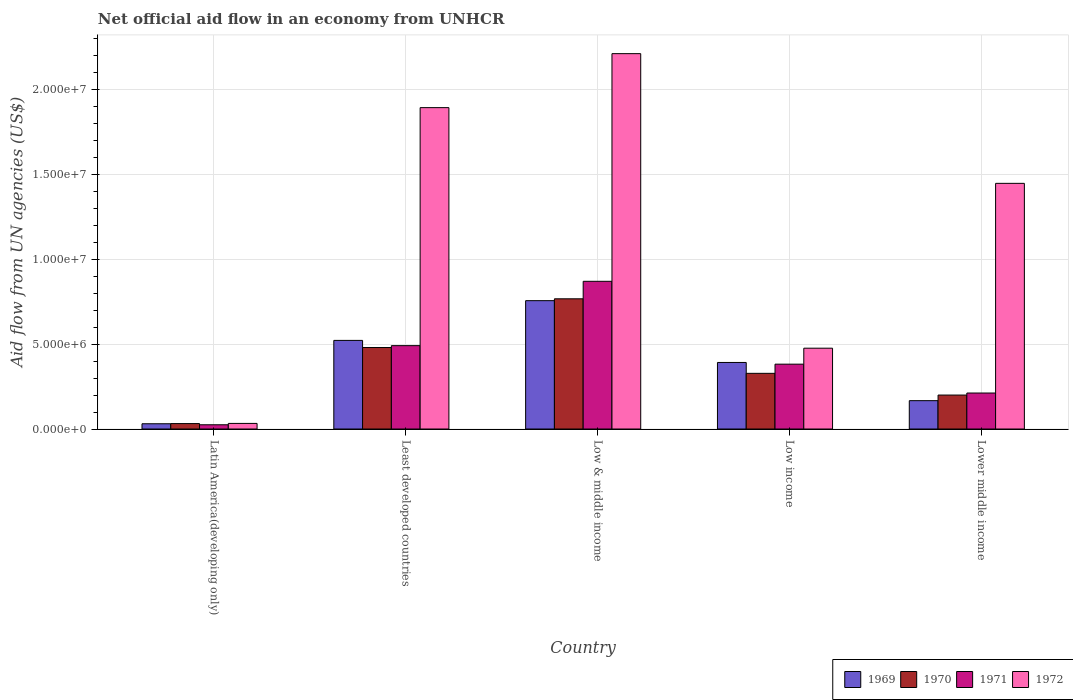How many different coloured bars are there?
Offer a terse response. 4. Are the number of bars on each tick of the X-axis equal?
Your response must be concise. Yes. How many bars are there on the 3rd tick from the left?
Keep it short and to the point. 4. How many bars are there on the 1st tick from the right?
Your answer should be compact. 4. What is the label of the 5th group of bars from the left?
Offer a terse response. Lower middle income. In how many cases, is the number of bars for a given country not equal to the number of legend labels?
Your answer should be very brief. 0. What is the net official aid flow in 1972 in Low & middle income?
Make the answer very short. 2.21e+07. Across all countries, what is the maximum net official aid flow in 1972?
Your answer should be very brief. 2.21e+07. Across all countries, what is the minimum net official aid flow in 1971?
Your response must be concise. 2.50e+05. In which country was the net official aid flow in 1971 maximum?
Provide a short and direct response. Low & middle income. In which country was the net official aid flow in 1971 minimum?
Your answer should be very brief. Latin America(developing only). What is the total net official aid flow in 1972 in the graph?
Keep it short and to the point. 6.06e+07. What is the difference between the net official aid flow in 1969 in Latin America(developing only) and that in Least developed countries?
Your answer should be compact. -4.91e+06. What is the difference between the net official aid flow in 1972 in Least developed countries and the net official aid flow in 1971 in Latin America(developing only)?
Your answer should be compact. 1.87e+07. What is the average net official aid flow in 1971 per country?
Provide a short and direct response. 3.96e+06. What is the difference between the net official aid flow of/in 1972 and net official aid flow of/in 1971 in Lower middle income?
Your answer should be compact. 1.24e+07. What is the ratio of the net official aid flow in 1969 in Latin America(developing only) to that in Low income?
Your answer should be compact. 0.08. Is the net official aid flow in 1972 in Least developed countries less than that in Low & middle income?
Keep it short and to the point. Yes. What is the difference between the highest and the second highest net official aid flow in 1970?
Offer a very short reply. 2.87e+06. What is the difference between the highest and the lowest net official aid flow in 1972?
Provide a succinct answer. 2.18e+07. What does the 3rd bar from the left in Latin America(developing only) represents?
Give a very brief answer. 1971. What does the 4th bar from the right in Lower middle income represents?
Give a very brief answer. 1969. Is it the case that in every country, the sum of the net official aid flow in 1969 and net official aid flow in 1970 is greater than the net official aid flow in 1972?
Provide a short and direct response. No. How many bars are there?
Your response must be concise. 20. Are all the bars in the graph horizontal?
Ensure brevity in your answer.  No. How many countries are there in the graph?
Your answer should be compact. 5. Are the values on the major ticks of Y-axis written in scientific E-notation?
Make the answer very short. Yes. Does the graph contain any zero values?
Ensure brevity in your answer.  No. Does the graph contain grids?
Give a very brief answer. Yes. What is the title of the graph?
Your answer should be very brief. Net official aid flow in an economy from UNHCR. What is the label or title of the Y-axis?
Provide a succinct answer. Aid flow from UN agencies (US$). What is the Aid flow from UN agencies (US$) in 1970 in Latin America(developing only)?
Provide a short and direct response. 3.20e+05. What is the Aid flow from UN agencies (US$) of 1971 in Latin America(developing only)?
Your response must be concise. 2.50e+05. What is the Aid flow from UN agencies (US$) in 1972 in Latin America(developing only)?
Offer a terse response. 3.30e+05. What is the Aid flow from UN agencies (US$) in 1969 in Least developed countries?
Provide a succinct answer. 5.22e+06. What is the Aid flow from UN agencies (US$) of 1970 in Least developed countries?
Keep it short and to the point. 4.80e+06. What is the Aid flow from UN agencies (US$) of 1971 in Least developed countries?
Keep it short and to the point. 4.91e+06. What is the Aid flow from UN agencies (US$) of 1972 in Least developed countries?
Make the answer very short. 1.89e+07. What is the Aid flow from UN agencies (US$) in 1969 in Low & middle income?
Your response must be concise. 7.56e+06. What is the Aid flow from UN agencies (US$) in 1970 in Low & middle income?
Make the answer very short. 7.67e+06. What is the Aid flow from UN agencies (US$) of 1971 in Low & middle income?
Your answer should be compact. 8.70e+06. What is the Aid flow from UN agencies (US$) in 1972 in Low & middle income?
Give a very brief answer. 2.21e+07. What is the Aid flow from UN agencies (US$) of 1969 in Low income?
Provide a succinct answer. 3.92e+06. What is the Aid flow from UN agencies (US$) in 1970 in Low income?
Offer a terse response. 3.28e+06. What is the Aid flow from UN agencies (US$) of 1971 in Low income?
Ensure brevity in your answer.  3.82e+06. What is the Aid flow from UN agencies (US$) in 1972 in Low income?
Keep it short and to the point. 4.76e+06. What is the Aid flow from UN agencies (US$) of 1969 in Lower middle income?
Give a very brief answer. 1.67e+06. What is the Aid flow from UN agencies (US$) of 1971 in Lower middle income?
Offer a very short reply. 2.12e+06. What is the Aid flow from UN agencies (US$) in 1972 in Lower middle income?
Provide a succinct answer. 1.45e+07. Across all countries, what is the maximum Aid flow from UN agencies (US$) in 1969?
Offer a terse response. 7.56e+06. Across all countries, what is the maximum Aid flow from UN agencies (US$) of 1970?
Make the answer very short. 7.67e+06. Across all countries, what is the maximum Aid flow from UN agencies (US$) in 1971?
Make the answer very short. 8.70e+06. Across all countries, what is the maximum Aid flow from UN agencies (US$) of 1972?
Offer a very short reply. 2.21e+07. Across all countries, what is the minimum Aid flow from UN agencies (US$) in 1970?
Ensure brevity in your answer.  3.20e+05. What is the total Aid flow from UN agencies (US$) in 1969 in the graph?
Offer a very short reply. 1.87e+07. What is the total Aid flow from UN agencies (US$) of 1970 in the graph?
Your answer should be very brief. 1.81e+07. What is the total Aid flow from UN agencies (US$) of 1971 in the graph?
Provide a succinct answer. 1.98e+07. What is the total Aid flow from UN agencies (US$) in 1972 in the graph?
Your answer should be very brief. 6.06e+07. What is the difference between the Aid flow from UN agencies (US$) of 1969 in Latin America(developing only) and that in Least developed countries?
Your response must be concise. -4.91e+06. What is the difference between the Aid flow from UN agencies (US$) of 1970 in Latin America(developing only) and that in Least developed countries?
Give a very brief answer. -4.48e+06. What is the difference between the Aid flow from UN agencies (US$) in 1971 in Latin America(developing only) and that in Least developed countries?
Give a very brief answer. -4.66e+06. What is the difference between the Aid flow from UN agencies (US$) of 1972 in Latin America(developing only) and that in Least developed countries?
Ensure brevity in your answer.  -1.86e+07. What is the difference between the Aid flow from UN agencies (US$) of 1969 in Latin America(developing only) and that in Low & middle income?
Ensure brevity in your answer.  -7.25e+06. What is the difference between the Aid flow from UN agencies (US$) of 1970 in Latin America(developing only) and that in Low & middle income?
Make the answer very short. -7.35e+06. What is the difference between the Aid flow from UN agencies (US$) of 1971 in Latin America(developing only) and that in Low & middle income?
Ensure brevity in your answer.  -8.45e+06. What is the difference between the Aid flow from UN agencies (US$) of 1972 in Latin America(developing only) and that in Low & middle income?
Give a very brief answer. -2.18e+07. What is the difference between the Aid flow from UN agencies (US$) of 1969 in Latin America(developing only) and that in Low income?
Give a very brief answer. -3.61e+06. What is the difference between the Aid flow from UN agencies (US$) of 1970 in Latin America(developing only) and that in Low income?
Offer a terse response. -2.96e+06. What is the difference between the Aid flow from UN agencies (US$) of 1971 in Latin America(developing only) and that in Low income?
Your answer should be compact. -3.57e+06. What is the difference between the Aid flow from UN agencies (US$) in 1972 in Latin America(developing only) and that in Low income?
Keep it short and to the point. -4.43e+06. What is the difference between the Aid flow from UN agencies (US$) in 1969 in Latin America(developing only) and that in Lower middle income?
Provide a short and direct response. -1.36e+06. What is the difference between the Aid flow from UN agencies (US$) in 1970 in Latin America(developing only) and that in Lower middle income?
Your answer should be compact. -1.68e+06. What is the difference between the Aid flow from UN agencies (US$) of 1971 in Latin America(developing only) and that in Lower middle income?
Provide a succinct answer. -1.87e+06. What is the difference between the Aid flow from UN agencies (US$) in 1972 in Latin America(developing only) and that in Lower middle income?
Offer a terse response. -1.41e+07. What is the difference between the Aid flow from UN agencies (US$) of 1969 in Least developed countries and that in Low & middle income?
Your answer should be compact. -2.34e+06. What is the difference between the Aid flow from UN agencies (US$) of 1970 in Least developed countries and that in Low & middle income?
Your answer should be compact. -2.87e+06. What is the difference between the Aid flow from UN agencies (US$) in 1971 in Least developed countries and that in Low & middle income?
Offer a terse response. -3.79e+06. What is the difference between the Aid flow from UN agencies (US$) of 1972 in Least developed countries and that in Low & middle income?
Your answer should be compact. -3.18e+06. What is the difference between the Aid flow from UN agencies (US$) of 1969 in Least developed countries and that in Low income?
Your response must be concise. 1.30e+06. What is the difference between the Aid flow from UN agencies (US$) in 1970 in Least developed countries and that in Low income?
Keep it short and to the point. 1.52e+06. What is the difference between the Aid flow from UN agencies (US$) in 1971 in Least developed countries and that in Low income?
Your answer should be very brief. 1.09e+06. What is the difference between the Aid flow from UN agencies (US$) in 1972 in Least developed countries and that in Low income?
Offer a terse response. 1.42e+07. What is the difference between the Aid flow from UN agencies (US$) in 1969 in Least developed countries and that in Lower middle income?
Provide a short and direct response. 3.55e+06. What is the difference between the Aid flow from UN agencies (US$) in 1970 in Least developed countries and that in Lower middle income?
Your response must be concise. 2.80e+06. What is the difference between the Aid flow from UN agencies (US$) in 1971 in Least developed countries and that in Lower middle income?
Provide a succinct answer. 2.79e+06. What is the difference between the Aid flow from UN agencies (US$) of 1972 in Least developed countries and that in Lower middle income?
Provide a short and direct response. 4.46e+06. What is the difference between the Aid flow from UN agencies (US$) of 1969 in Low & middle income and that in Low income?
Your answer should be compact. 3.64e+06. What is the difference between the Aid flow from UN agencies (US$) of 1970 in Low & middle income and that in Low income?
Your response must be concise. 4.39e+06. What is the difference between the Aid flow from UN agencies (US$) of 1971 in Low & middle income and that in Low income?
Offer a very short reply. 4.88e+06. What is the difference between the Aid flow from UN agencies (US$) of 1972 in Low & middle income and that in Low income?
Provide a short and direct response. 1.74e+07. What is the difference between the Aid flow from UN agencies (US$) in 1969 in Low & middle income and that in Lower middle income?
Provide a short and direct response. 5.89e+06. What is the difference between the Aid flow from UN agencies (US$) of 1970 in Low & middle income and that in Lower middle income?
Your answer should be compact. 5.67e+06. What is the difference between the Aid flow from UN agencies (US$) of 1971 in Low & middle income and that in Lower middle income?
Offer a very short reply. 6.58e+06. What is the difference between the Aid flow from UN agencies (US$) in 1972 in Low & middle income and that in Lower middle income?
Keep it short and to the point. 7.64e+06. What is the difference between the Aid flow from UN agencies (US$) in 1969 in Low income and that in Lower middle income?
Give a very brief answer. 2.25e+06. What is the difference between the Aid flow from UN agencies (US$) of 1970 in Low income and that in Lower middle income?
Provide a succinct answer. 1.28e+06. What is the difference between the Aid flow from UN agencies (US$) in 1971 in Low income and that in Lower middle income?
Keep it short and to the point. 1.70e+06. What is the difference between the Aid flow from UN agencies (US$) in 1972 in Low income and that in Lower middle income?
Ensure brevity in your answer.  -9.71e+06. What is the difference between the Aid flow from UN agencies (US$) of 1969 in Latin America(developing only) and the Aid flow from UN agencies (US$) of 1970 in Least developed countries?
Offer a terse response. -4.49e+06. What is the difference between the Aid flow from UN agencies (US$) in 1969 in Latin America(developing only) and the Aid flow from UN agencies (US$) in 1971 in Least developed countries?
Your answer should be compact. -4.60e+06. What is the difference between the Aid flow from UN agencies (US$) of 1969 in Latin America(developing only) and the Aid flow from UN agencies (US$) of 1972 in Least developed countries?
Your answer should be very brief. -1.86e+07. What is the difference between the Aid flow from UN agencies (US$) in 1970 in Latin America(developing only) and the Aid flow from UN agencies (US$) in 1971 in Least developed countries?
Provide a succinct answer. -4.59e+06. What is the difference between the Aid flow from UN agencies (US$) of 1970 in Latin America(developing only) and the Aid flow from UN agencies (US$) of 1972 in Least developed countries?
Make the answer very short. -1.86e+07. What is the difference between the Aid flow from UN agencies (US$) in 1971 in Latin America(developing only) and the Aid flow from UN agencies (US$) in 1972 in Least developed countries?
Keep it short and to the point. -1.87e+07. What is the difference between the Aid flow from UN agencies (US$) of 1969 in Latin America(developing only) and the Aid flow from UN agencies (US$) of 1970 in Low & middle income?
Your response must be concise. -7.36e+06. What is the difference between the Aid flow from UN agencies (US$) in 1969 in Latin America(developing only) and the Aid flow from UN agencies (US$) in 1971 in Low & middle income?
Ensure brevity in your answer.  -8.39e+06. What is the difference between the Aid flow from UN agencies (US$) in 1969 in Latin America(developing only) and the Aid flow from UN agencies (US$) in 1972 in Low & middle income?
Provide a succinct answer. -2.18e+07. What is the difference between the Aid flow from UN agencies (US$) of 1970 in Latin America(developing only) and the Aid flow from UN agencies (US$) of 1971 in Low & middle income?
Provide a short and direct response. -8.38e+06. What is the difference between the Aid flow from UN agencies (US$) in 1970 in Latin America(developing only) and the Aid flow from UN agencies (US$) in 1972 in Low & middle income?
Your response must be concise. -2.18e+07. What is the difference between the Aid flow from UN agencies (US$) in 1971 in Latin America(developing only) and the Aid flow from UN agencies (US$) in 1972 in Low & middle income?
Your answer should be compact. -2.19e+07. What is the difference between the Aid flow from UN agencies (US$) in 1969 in Latin America(developing only) and the Aid flow from UN agencies (US$) in 1970 in Low income?
Keep it short and to the point. -2.97e+06. What is the difference between the Aid flow from UN agencies (US$) in 1969 in Latin America(developing only) and the Aid flow from UN agencies (US$) in 1971 in Low income?
Your response must be concise. -3.51e+06. What is the difference between the Aid flow from UN agencies (US$) of 1969 in Latin America(developing only) and the Aid flow from UN agencies (US$) of 1972 in Low income?
Your answer should be compact. -4.45e+06. What is the difference between the Aid flow from UN agencies (US$) of 1970 in Latin America(developing only) and the Aid flow from UN agencies (US$) of 1971 in Low income?
Your response must be concise. -3.50e+06. What is the difference between the Aid flow from UN agencies (US$) of 1970 in Latin America(developing only) and the Aid flow from UN agencies (US$) of 1972 in Low income?
Provide a succinct answer. -4.44e+06. What is the difference between the Aid flow from UN agencies (US$) of 1971 in Latin America(developing only) and the Aid flow from UN agencies (US$) of 1972 in Low income?
Offer a terse response. -4.51e+06. What is the difference between the Aid flow from UN agencies (US$) in 1969 in Latin America(developing only) and the Aid flow from UN agencies (US$) in 1970 in Lower middle income?
Your answer should be very brief. -1.69e+06. What is the difference between the Aid flow from UN agencies (US$) of 1969 in Latin America(developing only) and the Aid flow from UN agencies (US$) of 1971 in Lower middle income?
Provide a short and direct response. -1.81e+06. What is the difference between the Aid flow from UN agencies (US$) of 1969 in Latin America(developing only) and the Aid flow from UN agencies (US$) of 1972 in Lower middle income?
Ensure brevity in your answer.  -1.42e+07. What is the difference between the Aid flow from UN agencies (US$) in 1970 in Latin America(developing only) and the Aid flow from UN agencies (US$) in 1971 in Lower middle income?
Make the answer very short. -1.80e+06. What is the difference between the Aid flow from UN agencies (US$) in 1970 in Latin America(developing only) and the Aid flow from UN agencies (US$) in 1972 in Lower middle income?
Your answer should be compact. -1.42e+07. What is the difference between the Aid flow from UN agencies (US$) of 1971 in Latin America(developing only) and the Aid flow from UN agencies (US$) of 1972 in Lower middle income?
Provide a short and direct response. -1.42e+07. What is the difference between the Aid flow from UN agencies (US$) in 1969 in Least developed countries and the Aid flow from UN agencies (US$) in 1970 in Low & middle income?
Provide a short and direct response. -2.45e+06. What is the difference between the Aid flow from UN agencies (US$) in 1969 in Least developed countries and the Aid flow from UN agencies (US$) in 1971 in Low & middle income?
Offer a terse response. -3.48e+06. What is the difference between the Aid flow from UN agencies (US$) in 1969 in Least developed countries and the Aid flow from UN agencies (US$) in 1972 in Low & middle income?
Ensure brevity in your answer.  -1.69e+07. What is the difference between the Aid flow from UN agencies (US$) in 1970 in Least developed countries and the Aid flow from UN agencies (US$) in 1971 in Low & middle income?
Provide a succinct answer. -3.90e+06. What is the difference between the Aid flow from UN agencies (US$) of 1970 in Least developed countries and the Aid flow from UN agencies (US$) of 1972 in Low & middle income?
Your answer should be very brief. -1.73e+07. What is the difference between the Aid flow from UN agencies (US$) in 1971 in Least developed countries and the Aid flow from UN agencies (US$) in 1972 in Low & middle income?
Offer a very short reply. -1.72e+07. What is the difference between the Aid flow from UN agencies (US$) in 1969 in Least developed countries and the Aid flow from UN agencies (US$) in 1970 in Low income?
Give a very brief answer. 1.94e+06. What is the difference between the Aid flow from UN agencies (US$) of 1969 in Least developed countries and the Aid flow from UN agencies (US$) of 1971 in Low income?
Offer a terse response. 1.40e+06. What is the difference between the Aid flow from UN agencies (US$) in 1969 in Least developed countries and the Aid flow from UN agencies (US$) in 1972 in Low income?
Provide a succinct answer. 4.60e+05. What is the difference between the Aid flow from UN agencies (US$) of 1970 in Least developed countries and the Aid flow from UN agencies (US$) of 1971 in Low income?
Your response must be concise. 9.80e+05. What is the difference between the Aid flow from UN agencies (US$) in 1971 in Least developed countries and the Aid flow from UN agencies (US$) in 1972 in Low income?
Ensure brevity in your answer.  1.50e+05. What is the difference between the Aid flow from UN agencies (US$) in 1969 in Least developed countries and the Aid flow from UN agencies (US$) in 1970 in Lower middle income?
Your answer should be compact. 3.22e+06. What is the difference between the Aid flow from UN agencies (US$) of 1969 in Least developed countries and the Aid flow from UN agencies (US$) of 1971 in Lower middle income?
Provide a succinct answer. 3.10e+06. What is the difference between the Aid flow from UN agencies (US$) in 1969 in Least developed countries and the Aid flow from UN agencies (US$) in 1972 in Lower middle income?
Your response must be concise. -9.25e+06. What is the difference between the Aid flow from UN agencies (US$) in 1970 in Least developed countries and the Aid flow from UN agencies (US$) in 1971 in Lower middle income?
Keep it short and to the point. 2.68e+06. What is the difference between the Aid flow from UN agencies (US$) of 1970 in Least developed countries and the Aid flow from UN agencies (US$) of 1972 in Lower middle income?
Keep it short and to the point. -9.67e+06. What is the difference between the Aid flow from UN agencies (US$) in 1971 in Least developed countries and the Aid flow from UN agencies (US$) in 1972 in Lower middle income?
Ensure brevity in your answer.  -9.56e+06. What is the difference between the Aid flow from UN agencies (US$) in 1969 in Low & middle income and the Aid flow from UN agencies (US$) in 1970 in Low income?
Your answer should be very brief. 4.28e+06. What is the difference between the Aid flow from UN agencies (US$) in 1969 in Low & middle income and the Aid flow from UN agencies (US$) in 1971 in Low income?
Your response must be concise. 3.74e+06. What is the difference between the Aid flow from UN agencies (US$) in 1969 in Low & middle income and the Aid flow from UN agencies (US$) in 1972 in Low income?
Keep it short and to the point. 2.80e+06. What is the difference between the Aid flow from UN agencies (US$) in 1970 in Low & middle income and the Aid flow from UN agencies (US$) in 1971 in Low income?
Keep it short and to the point. 3.85e+06. What is the difference between the Aid flow from UN agencies (US$) of 1970 in Low & middle income and the Aid flow from UN agencies (US$) of 1972 in Low income?
Ensure brevity in your answer.  2.91e+06. What is the difference between the Aid flow from UN agencies (US$) of 1971 in Low & middle income and the Aid flow from UN agencies (US$) of 1972 in Low income?
Your answer should be compact. 3.94e+06. What is the difference between the Aid flow from UN agencies (US$) in 1969 in Low & middle income and the Aid flow from UN agencies (US$) in 1970 in Lower middle income?
Make the answer very short. 5.56e+06. What is the difference between the Aid flow from UN agencies (US$) of 1969 in Low & middle income and the Aid flow from UN agencies (US$) of 1971 in Lower middle income?
Provide a succinct answer. 5.44e+06. What is the difference between the Aid flow from UN agencies (US$) of 1969 in Low & middle income and the Aid flow from UN agencies (US$) of 1972 in Lower middle income?
Your answer should be very brief. -6.91e+06. What is the difference between the Aid flow from UN agencies (US$) of 1970 in Low & middle income and the Aid flow from UN agencies (US$) of 1971 in Lower middle income?
Your response must be concise. 5.55e+06. What is the difference between the Aid flow from UN agencies (US$) in 1970 in Low & middle income and the Aid flow from UN agencies (US$) in 1972 in Lower middle income?
Offer a terse response. -6.80e+06. What is the difference between the Aid flow from UN agencies (US$) of 1971 in Low & middle income and the Aid flow from UN agencies (US$) of 1972 in Lower middle income?
Keep it short and to the point. -5.77e+06. What is the difference between the Aid flow from UN agencies (US$) in 1969 in Low income and the Aid flow from UN agencies (US$) in 1970 in Lower middle income?
Make the answer very short. 1.92e+06. What is the difference between the Aid flow from UN agencies (US$) of 1969 in Low income and the Aid flow from UN agencies (US$) of 1971 in Lower middle income?
Keep it short and to the point. 1.80e+06. What is the difference between the Aid flow from UN agencies (US$) of 1969 in Low income and the Aid flow from UN agencies (US$) of 1972 in Lower middle income?
Your answer should be very brief. -1.06e+07. What is the difference between the Aid flow from UN agencies (US$) of 1970 in Low income and the Aid flow from UN agencies (US$) of 1971 in Lower middle income?
Provide a short and direct response. 1.16e+06. What is the difference between the Aid flow from UN agencies (US$) in 1970 in Low income and the Aid flow from UN agencies (US$) in 1972 in Lower middle income?
Keep it short and to the point. -1.12e+07. What is the difference between the Aid flow from UN agencies (US$) of 1971 in Low income and the Aid flow from UN agencies (US$) of 1972 in Lower middle income?
Keep it short and to the point. -1.06e+07. What is the average Aid flow from UN agencies (US$) of 1969 per country?
Give a very brief answer. 3.74e+06. What is the average Aid flow from UN agencies (US$) of 1970 per country?
Provide a succinct answer. 3.61e+06. What is the average Aid flow from UN agencies (US$) in 1971 per country?
Ensure brevity in your answer.  3.96e+06. What is the average Aid flow from UN agencies (US$) of 1972 per country?
Provide a short and direct response. 1.21e+07. What is the difference between the Aid flow from UN agencies (US$) of 1969 and Aid flow from UN agencies (US$) of 1970 in Latin America(developing only)?
Offer a very short reply. -10000. What is the difference between the Aid flow from UN agencies (US$) in 1970 and Aid flow from UN agencies (US$) in 1971 in Latin America(developing only)?
Provide a short and direct response. 7.00e+04. What is the difference between the Aid flow from UN agencies (US$) of 1971 and Aid flow from UN agencies (US$) of 1972 in Latin America(developing only)?
Your response must be concise. -8.00e+04. What is the difference between the Aid flow from UN agencies (US$) in 1969 and Aid flow from UN agencies (US$) in 1972 in Least developed countries?
Ensure brevity in your answer.  -1.37e+07. What is the difference between the Aid flow from UN agencies (US$) in 1970 and Aid flow from UN agencies (US$) in 1972 in Least developed countries?
Ensure brevity in your answer.  -1.41e+07. What is the difference between the Aid flow from UN agencies (US$) of 1971 and Aid flow from UN agencies (US$) of 1972 in Least developed countries?
Provide a short and direct response. -1.40e+07. What is the difference between the Aid flow from UN agencies (US$) of 1969 and Aid flow from UN agencies (US$) of 1971 in Low & middle income?
Make the answer very short. -1.14e+06. What is the difference between the Aid flow from UN agencies (US$) in 1969 and Aid flow from UN agencies (US$) in 1972 in Low & middle income?
Make the answer very short. -1.46e+07. What is the difference between the Aid flow from UN agencies (US$) in 1970 and Aid flow from UN agencies (US$) in 1971 in Low & middle income?
Ensure brevity in your answer.  -1.03e+06. What is the difference between the Aid flow from UN agencies (US$) of 1970 and Aid flow from UN agencies (US$) of 1972 in Low & middle income?
Your response must be concise. -1.44e+07. What is the difference between the Aid flow from UN agencies (US$) in 1971 and Aid flow from UN agencies (US$) in 1972 in Low & middle income?
Offer a very short reply. -1.34e+07. What is the difference between the Aid flow from UN agencies (US$) of 1969 and Aid flow from UN agencies (US$) of 1970 in Low income?
Your response must be concise. 6.40e+05. What is the difference between the Aid flow from UN agencies (US$) in 1969 and Aid flow from UN agencies (US$) in 1972 in Low income?
Keep it short and to the point. -8.40e+05. What is the difference between the Aid flow from UN agencies (US$) in 1970 and Aid flow from UN agencies (US$) in 1971 in Low income?
Your answer should be very brief. -5.40e+05. What is the difference between the Aid flow from UN agencies (US$) in 1970 and Aid flow from UN agencies (US$) in 1972 in Low income?
Ensure brevity in your answer.  -1.48e+06. What is the difference between the Aid flow from UN agencies (US$) of 1971 and Aid flow from UN agencies (US$) of 1972 in Low income?
Keep it short and to the point. -9.40e+05. What is the difference between the Aid flow from UN agencies (US$) in 1969 and Aid flow from UN agencies (US$) in 1970 in Lower middle income?
Your answer should be compact. -3.30e+05. What is the difference between the Aid flow from UN agencies (US$) in 1969 and Aid flow from UN agencies (US$) in 1971 in Lower middle income?
Offer a terse response. -4.50e+05. What is the difference between the Aid flow from UN agencies (US$) in 1969 and Aid flow from UN agencies (US$) in 1972 in Lower middle income?
Your answer should be compact. -1.28e+07. What is the difference between the Aid flow from UN agencies (US$) in 1970 and Aid flow from UN agencies (US$) in 1972 in Lower middle income?
Provide a succinct answer. -1.25e+07. What is the difference between the Aid flow from UN agencies (US$) of 1971 and Aid flow from UN agencies (US$) of 1972 in Lower middle income?
Your answer should be very brief. -1.24e+07. What is the ratio of the Aid flow from UN agencies (US$) in 1969 in Latin America(developing only) to that in Least developed countries?
Give a very brief answer. 0.06. What is the ratio of the Aid flow from UN agencies (US$) of 1970 in Latin America(developing only) to that in Least developed countries?
Your response must be concise. 0.07. What is the ratio of the Aid flow from UN agencies (US$) in 1971 in Latin America(developing only) to that in Least developed countries?
Your response must be concise. 0.05. What is the ratio of the Aid flow from UN agencies (US$) of 1972 in Latin America(developing only) to that in Least developed countries?
Your answer should be compact. 0.02. What is the ratio of the Aid flow from UN agencies (US$) in 1969 in Latin America(developing only) to that in Low & middle income?
Offer a terse response. 0.04. What is the ratio of the Aid flow from UN agencies (US$) in 1970 in Latin America(developing only) to that in Low & middle income?
Your response must be concise. 0.04. What is the ratio of the Aid flow from UN agencies (US$) of 1971 in Latin America(developing only) to that in Low & middle income?
Your response must be concise. 0.03. What is the ratio of the Aid flow from UN agencies (US$) in 1972 in Latin America(developing only) to that in Low & middle income?
Ensure brevity in your answer.  0.01. What is the ratio of the Aid flow from UN agencies (US$) of 1969 in Latin America(developing only) to that in Low income?
Provide a short and direct response. 0.08. What is the ratio of the Aid flow from UN agencies (US$) of 1970 in Latin America(developing only) to that in Low income?
Offer a very short reply. 0.1. What is the ratio of the Aid flow from UN agencies (US$) in 1971 in Latin America(developing only) to that in Low income?
Provide a short and direct response. 0.07. What is the ratio of the Aid flow from UN agencies (US$) of 1972 in Latin America(developing only) to that in Low income?
Make the answer very short. 0.07. What is the ratio of the Aid flow from UN agencies (US$) in 1969 in Latin America(developing only) to that in Lower middle income?
Give a very brief answer. 0.19. What is the ratio of the Aid flow from UN agencies (US$) in 1970 in Latin America(developing only) to that in Lower middle income?
Your response must be concise. 0.16. What is the ratio of the Aid flow from UN agencies (US$) in 1971 in Latin America(developing only) to that in Lower middle income?
Offer a terse response. 0.12. What is the ratio of the Aid flow from UN agencies (US$) of 1972 in Latin America(developing only) to that in Lower middle income?
Your answer should be compact. 0.02. What is the ratio of the Aid flow from UN agencies (US$) of 1969 in Least developed countries to that in Low & middle income?
Your answer should be compact. 0.69. What is the ratio of the Aid flow from UN agencies (US$) in 1970 in Least developed countries to that in Low & middle income?
Ensure brevity in your answer.  0.63. What is the ratio of the Aid flow from UN agencies (US$) in 1971 in Least developed countries to that in Low & middle income?
Your response must be concise. 0.56. What is the ratio of the Aid flow from UN agencies (US$) in 1972 in Least developed countries to that in Low & middle income?
Ensure brevity in your answer.  0.86. What is the ratio of the Aid flow from UN agencies (US$) in 1969 in Least developed countries to that in Low income?
Your response must be concise. 1.33. What is the ratio of the Aid flow from UN agencies (US$) in 1970 in Least developed countries to that in Low income?
Keep it short and to the point. 1.46. What is the ratio of the Aid flow from UN agencies (US$) of 1971 in Least developed countries to that in Low income?
Your answer should be compact. 1.29. What is the ratio of the Aid flow from UN agencies (US$) in 1972 in Least developed countries to that in Low income?
Keep it short and to the point. 3.98. What is the ratio of the Aid flow from UN agencies (US$) of 1969 in Least developed countries to that in Lower middle income?
Make the answer very short. 3.13. What is the ratio of the Aid flow from UN agencies (US$) of 1971 in Least developed countries to that in Lower middle income?
Your answer should be compact. 2.32. What is the ratio of the Aid flow from UN agencies (US$) in 1972 in Least developed countries to that in Lower middle income?
Your response must be concise. 1.31. What is the ratio of the Aid flow from UN agencies (US$) in 1969 in Low & middle income to that in Low income?
Ensure brevity in your answer.  1.93. What is the ratio of the Aid flow from UN agencies (US$) in 1970 in Low & middle income to that in Low income?
Your answer should be very brief. 2.34. What is the ratio of the Aid flow from UN agencies (US$) in 1971 in Low & middle income to that in Low income?
Offer a very short reply. 2.28. What is the ratio of the Aid flow from UN agencies (US$) of 1972 in Low & middle income to that in Low income?
Offer a very short reply. 4.64. What is the ratio of the Aid flow from UN agencies (US$) in 1969 in Low & middle income to that in Lower middle income?
Offer a very short reply. 4.53. What is the ratio of the Aid flow from UN agencies (US$) of 1970 in Low & middle income to that in Lower middle income?
Your response must be concise. 3.83. What is the ratio of the Aid flow from UN agencies (US$) in 1971 in Low & middle income to that in Lower middle income?
Provide a succinct answer. 4.1. What is the ratio of the Aid flow from UN agencies (US$) in 1972 in Low & middle income to that in Lower middle income?
Provide a short and direct response. 1.53. What is the ratio of the Aid flow from UN agencies (US$) of 1969 in Low income to that in Lower middle income?
Provide a succinct answer. 2.35. What is the ratio of the Aid flow from UN agencies (US$) of 1970 in Low income to that in Lower middle income?
Make the answer very short. 1.64. What is the ratio of the Aid flow from UN agencies (US$) in 1971 in Low income to that in Lower middle income?
Offer a terse response. 1.8. What is the ratio of the Aid flow from UN agencies (US$) of 1972 in Low income to that in Lower middle income?
Give a very brief answer. 0.33. What is the difference between the highest and the second highest Aid flow from UN agencies (US$) in 1969?
Give a very brief answer. 2.34e+06. What is the difference between the highest and the second highest Aid flow from UN agencies (US$) of 1970?
Your answer should be compact. 2.87e+06. What is the difference between the highest and the second highest Aid flow from UN agencies (US$) in 1971?
Provide a succinct answer. 3.79e+06. What is the difference between the highest and the second highest Aid flow from UN agencies (US$) of 1972?
Keep it short and to the point. 3.18e+06. What is the difference between the highest and the lowest Aid flow from UN agencies (US$) in 1969?
Keep it short and to the point. 7.25e+06. What is the difference between the highest and the lowest Aid flow from UN agencies (US$) in 1970?
Provide a short and direct response. 7.35e+06. What is the difference between the highest and the lowest Aid flow from UN agencies (US$) in 1971?
Your answer should be very brief. 8.45e+06. What is the difference between the highest and the lowest Aid flow from UN agencies (US$) of 1972?
Provide a short and direct response. 2.18e+07. 